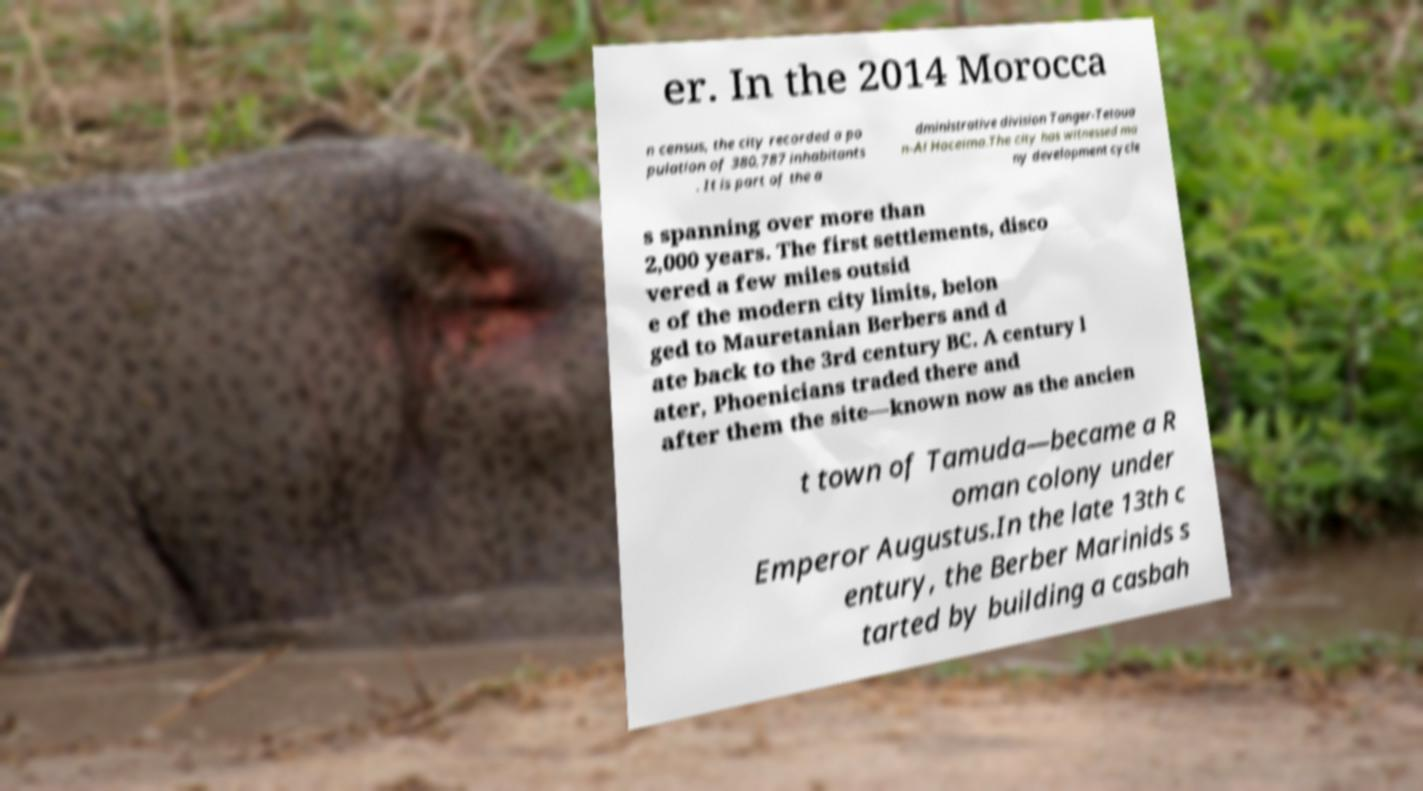I need the written content from this picture converted into text. Can you do that? er. In the 2014 Morocca n census, the city recorded a po pulation of 380,787 inhabitants . It is part of the a dministrative division Tanger-Tetoua n-Al Hoceima.The city has witnessed ma ny development cycle s spanning over more than 2,000 years. The first settlements, disco vered a few miles outsid e of the modern city limits, belon ged to Mauretanian Berbers and d ate back to the 3rd century BC. A century l ater, Phoenicians traded there and after them the site—known now as the ancien t town of Tamuda—became a R oman colony under Emperor Augustus.In the late 13th c entury, the Berber Marinids s tarted by building a casbah 